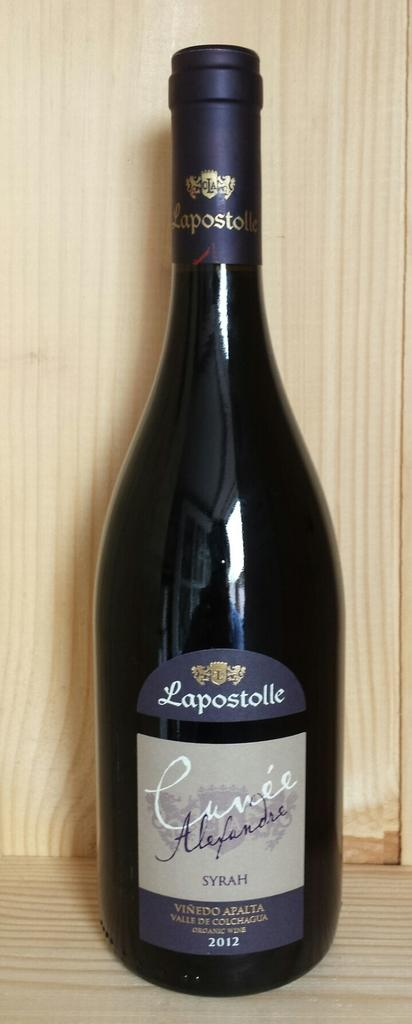Provide a one-sentence caption for the provided image. A wine bottle that is from Lapostolle vineyards. 